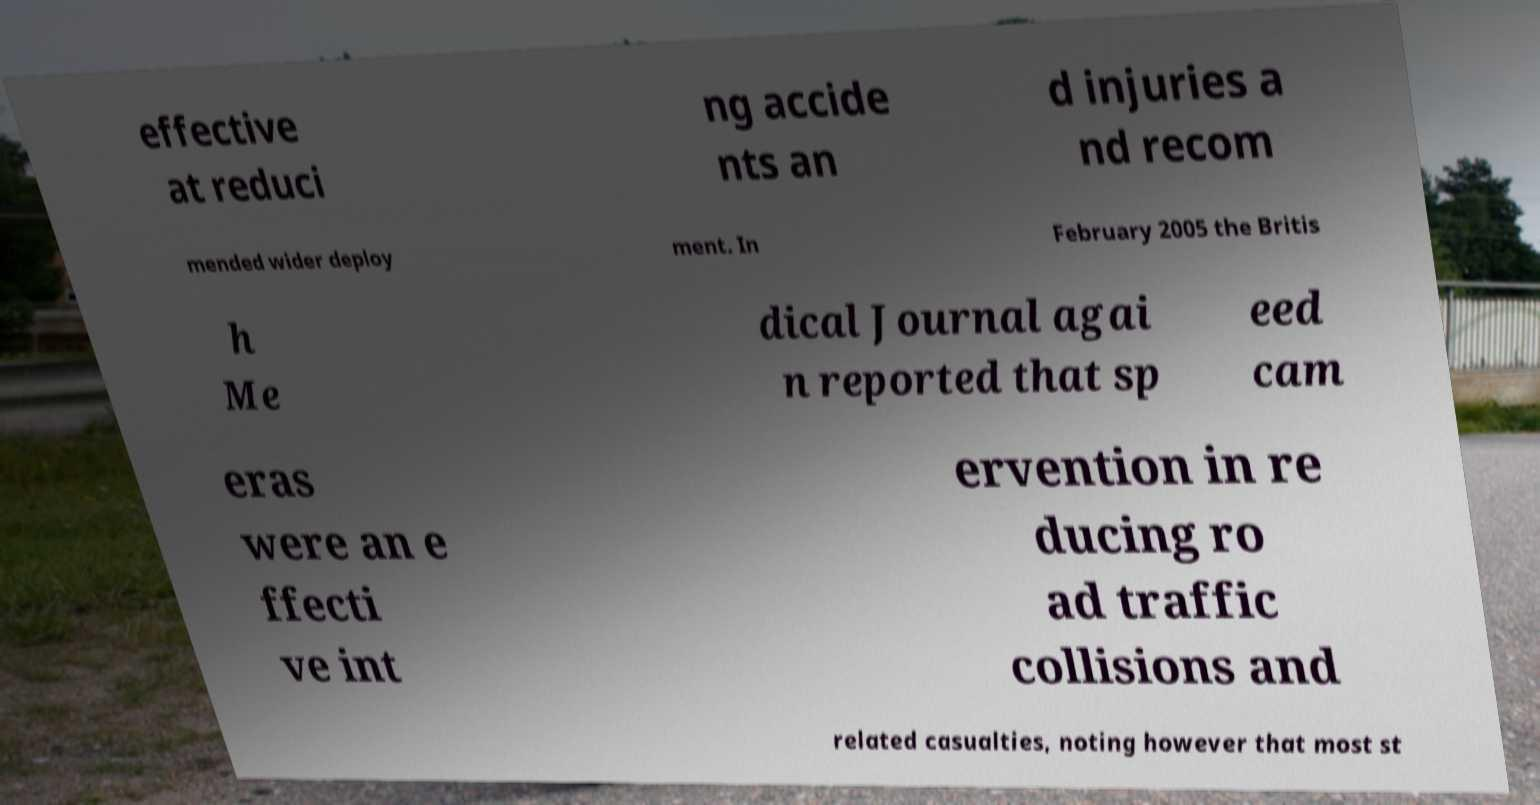Can you read and provide the text displayed in the image?This photo seems to have some interesting text. Can you extract and type it out for me? effective at reduci ng accide nts an d injuries a nd recom mended wider deploy ment. In February 2005 the Britis h Me dical Journal agai n reported that sp eed cam eras were an e ffecti ve int ervention in re ducing ro ad traffic collisions and related casualties, noting however that most st 